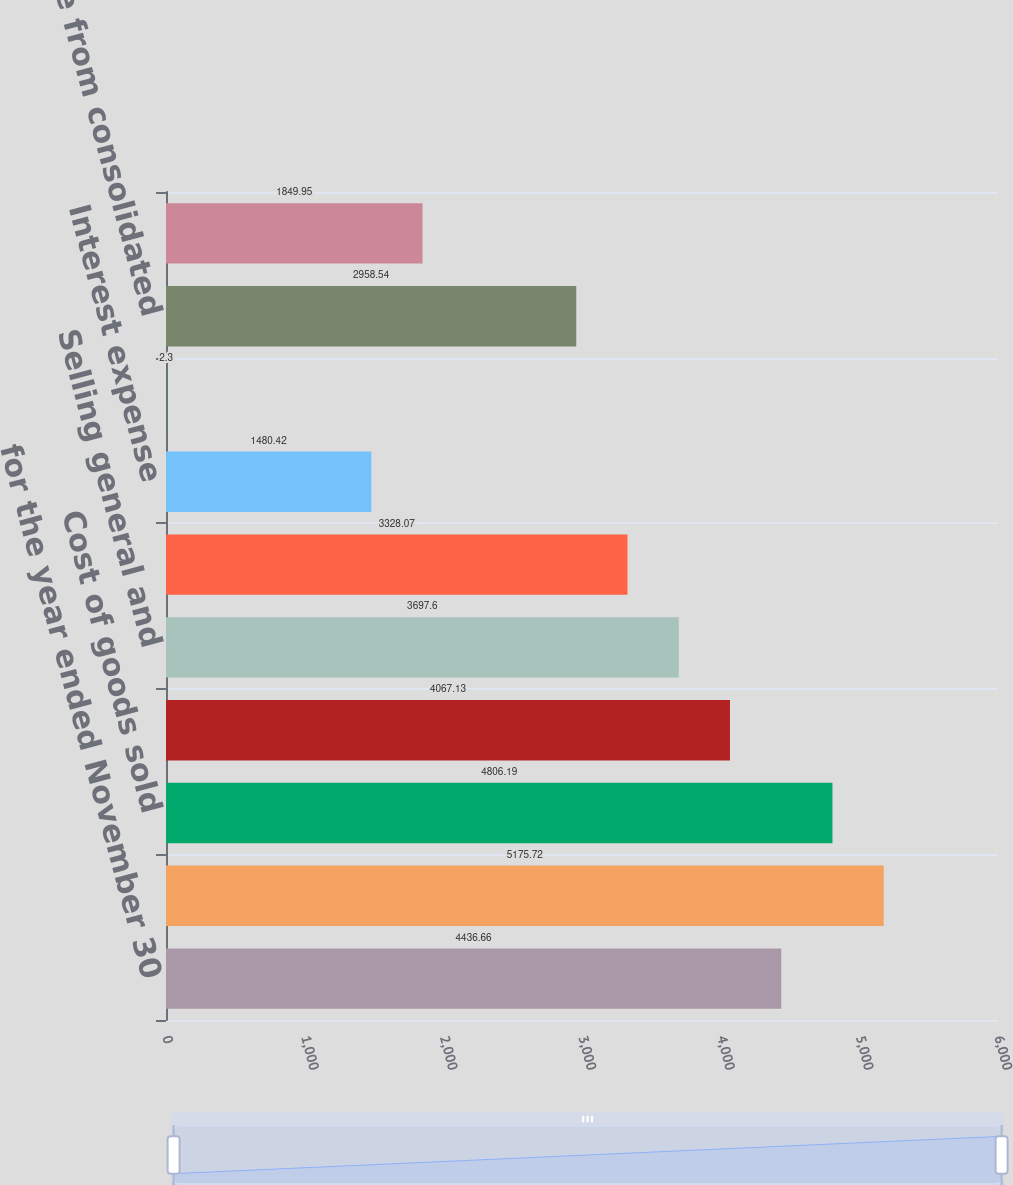Convert chart. <chart><loc_0><loc_0><loc_500><loc_500><bar_chart><fcel>for the year ended November 30<fcel>Net sales<fcel>Cost of goods sold<fcel>Gross profit<fcel>Selling general and<fcel>Operating income<fcel>Interest expense<fcel>Other income net<fcel>Income from consolidated<fcel>Income taxes<nl><fcel>4436.66<fcel>5175.72<fcel>4806.19<fcel>4067.13<fcel>3697.6<fcel>3328.07<fcel>1480.42<fcel>2.3<fcel>2958.54<fcel>1849.95<nl></chart> 